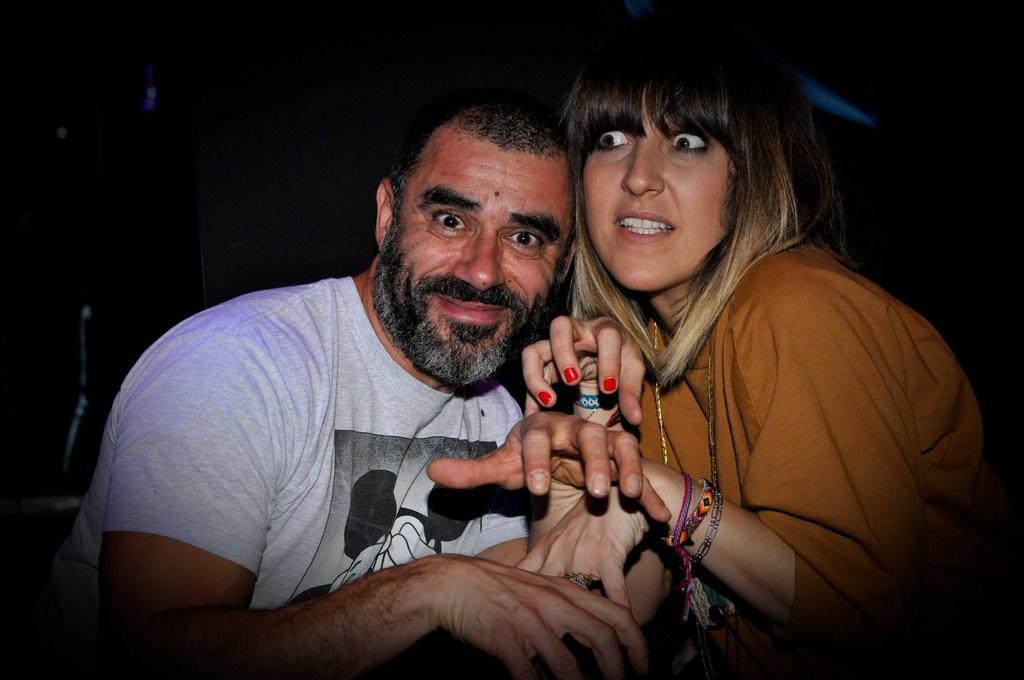Can you describe this image briefly? In this image we can see two persons and the background of the image is dark. 